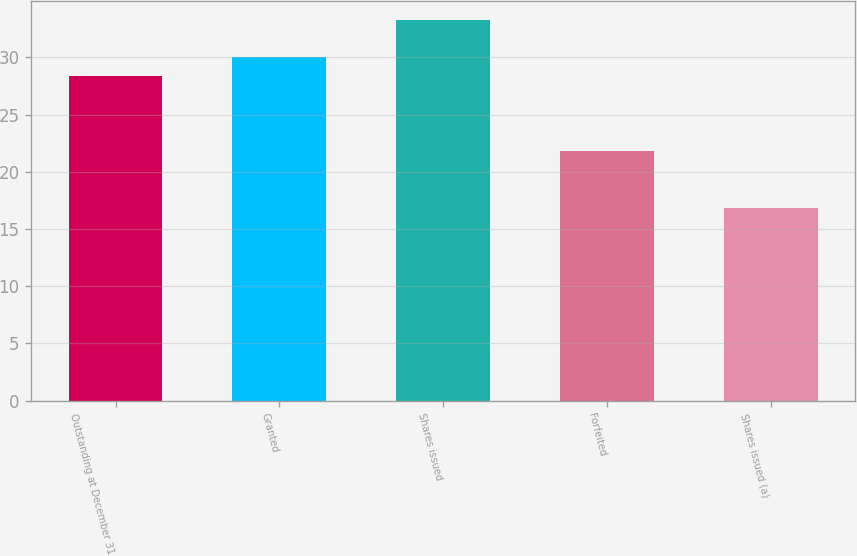Convert chart. <chart><loc_0><loc_0><loc_500><loc_500><bar_chart><fcel>Outstanding at December 31<fcel>Granted<fcel>Shares issued<fcel>Forfeited<fcel>Shares issued (a)<nl><fcel>28.39<fcel>30.03<fcel>33.25<fcel>21.83<fcel>16.83<nl></chart> 